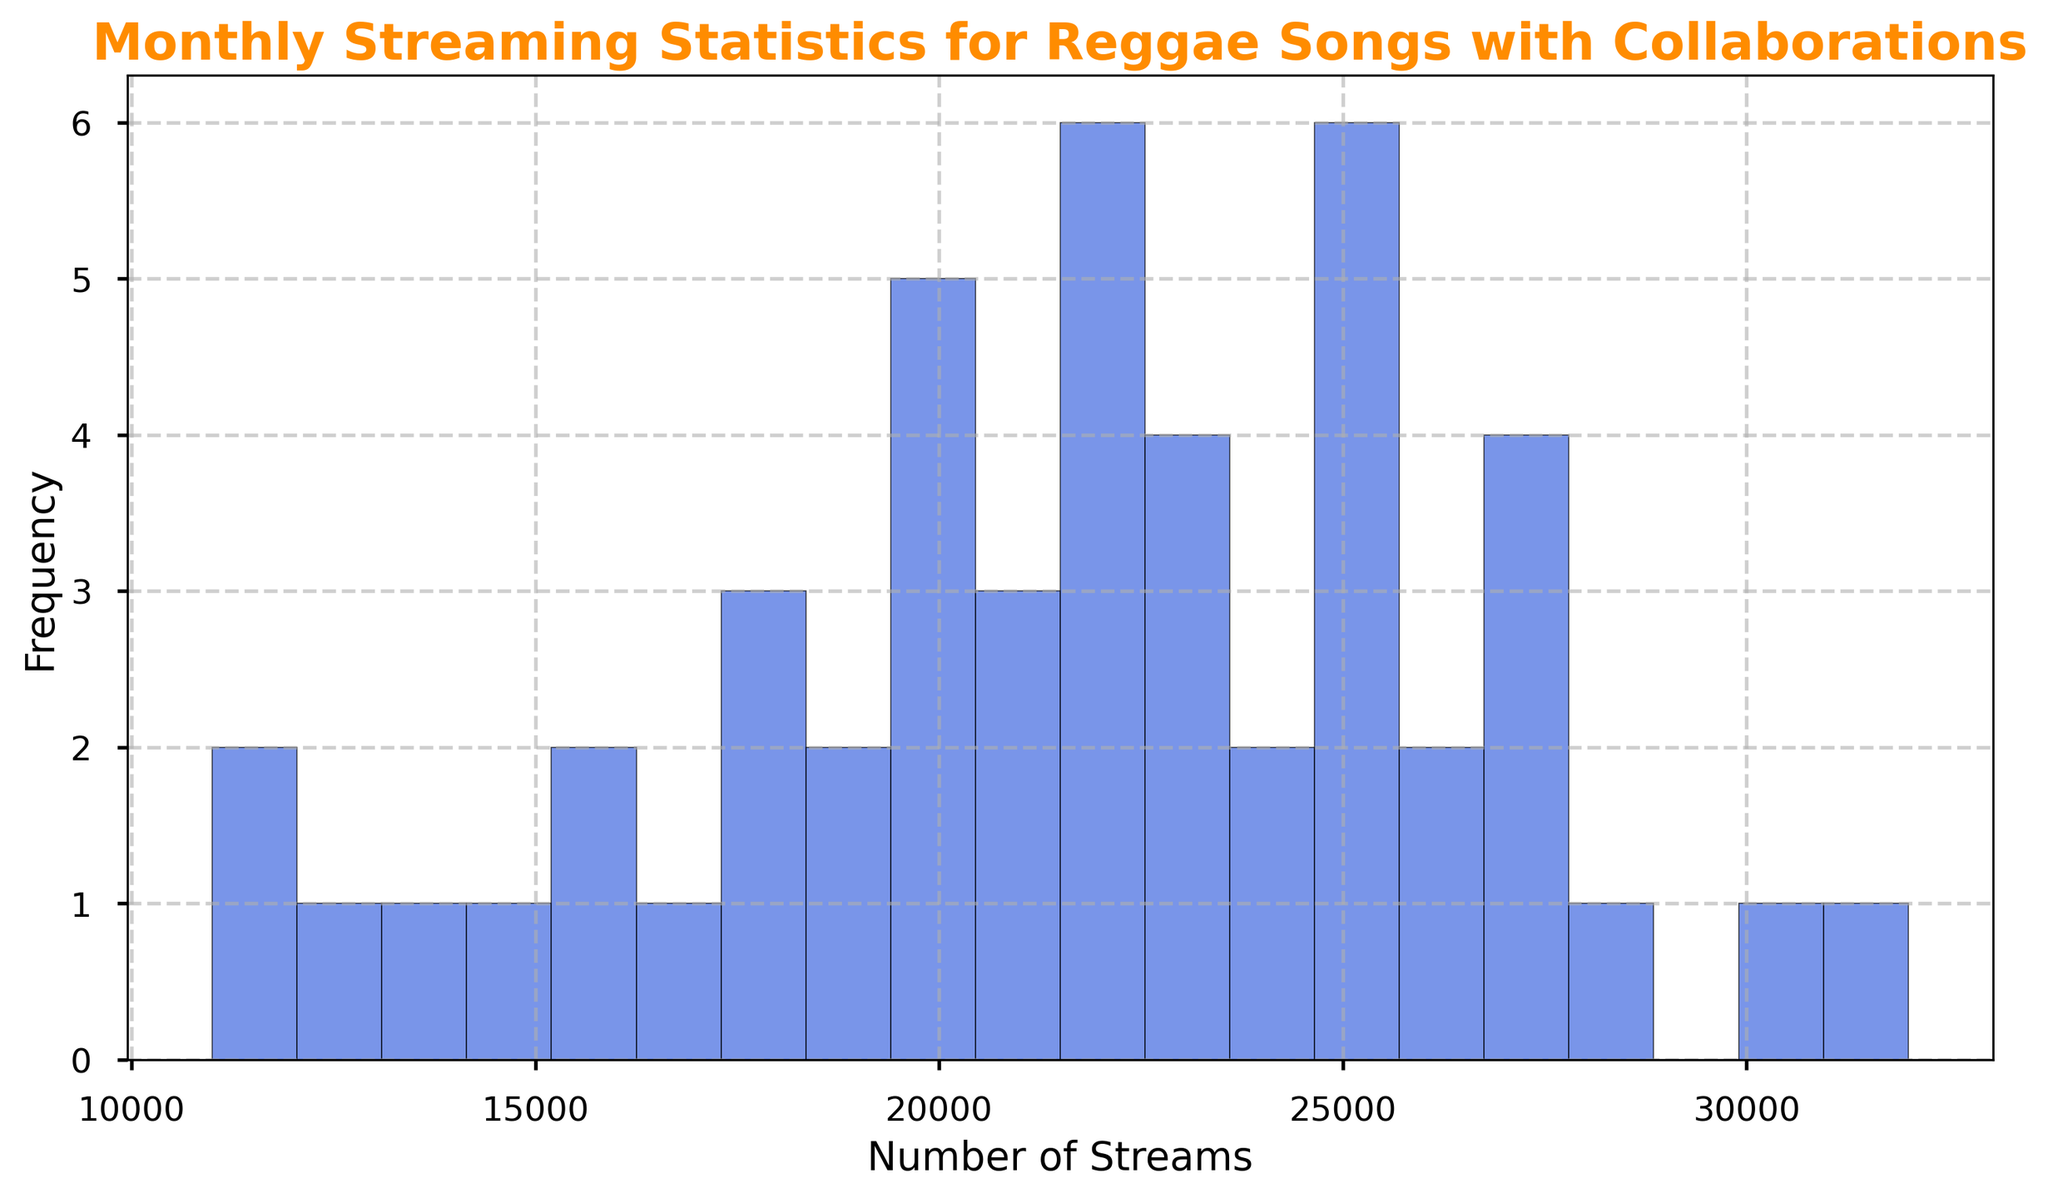What is the frequency of songs with 20,000 streams? In the histogram, identify the bar that represents 20,000 streams and check its height to determine the frequency.
Answer: 3 Which month had the highest number of streams for reggae collaborations? Looking at the data distribution in the histogram, the tail-end with higher values indicates December with streams reaching up to 32,000. This shows December had the highest streams.
Answer: December How many months have at least one song with more than 25,000 streams? By inspecting the histogram bins, we see significant activity near the higher stream counts. From the original data, this corresponds to April, August, October, November, and December. Count these months.
Answer: 5 What is the range of streams where the maximum frequency occurs? Examine the bar with the highest height on the histogram. Note the stream range it covers to determine where the frequency peaks.
Answer: 22,000 - 23,000 Are there more songs streamed less than 20,000 times or more than 20,000 times? Check the frequencies of the bins representing less than 20,000 streams and compare these to the frequencies of bins representing more than 20,000 streams. The bins under 20,000 are fewer.
Answer: More than 20,000 What is the approximate frequency of songs streamed between 24,000 and 26,000 times? Identify the bins covering the 24,000 to 26,000 stream range, and sum their heights.
Answer: 3 Which month or months have a minimum streaming count of at least 18,000? From the data, see which months have all entries above 18,000 streams. This matches April, July, August, October, November, and December.
Answer: April, July, August, October, November, December 